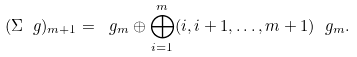Convert formula to latex. <formula><loc_0><loc_0><loc_500><loc_500>( \Sigma \ g ) _ { m + 1 } = \ g _ { m } \oplus \bigoplus _ { i = 1 } ^ { m } ( i , i + 1 , \dots , m + 1 ) \ g _ { m } .</formula> 